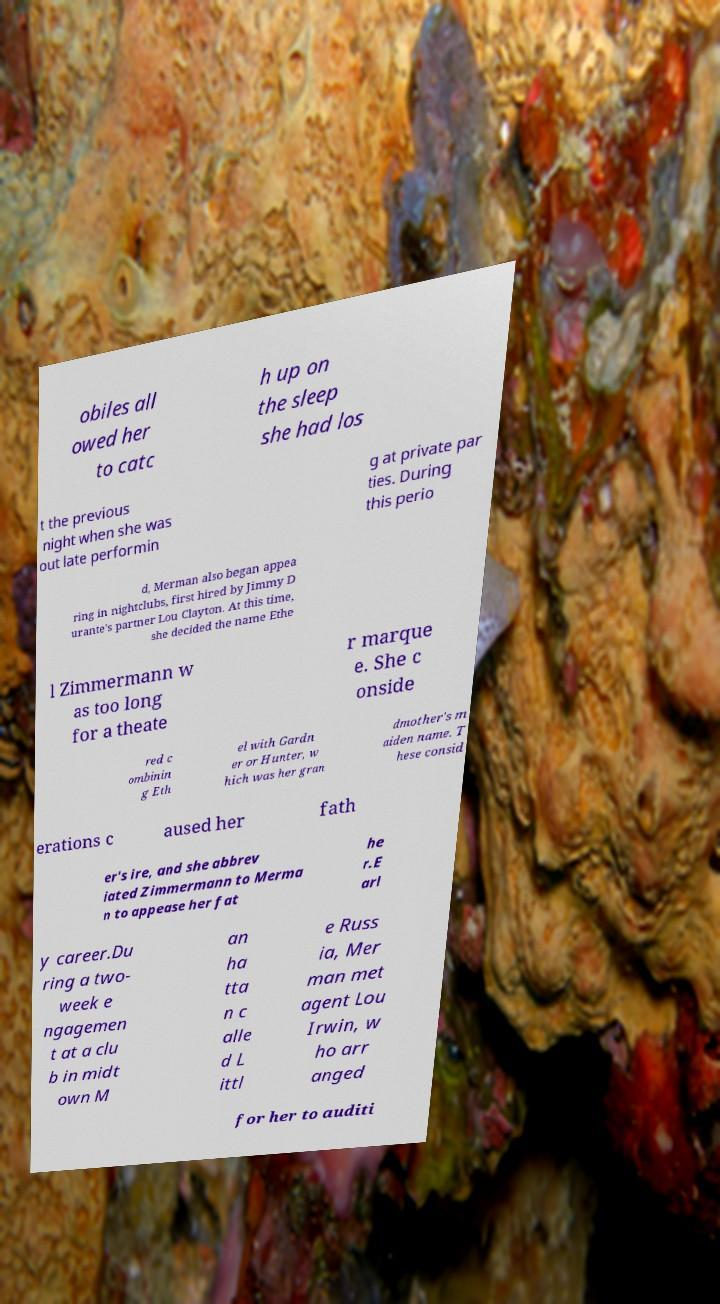Please identify and transcribe the text found in this image. obiles all owed her to catc h up on the sleep she had los t the previous night when she was out late performin g at private par ties. During this perio d, Merman also began appea ring in nightclubs, first hired by Jimmy D urante's partner Lou Clayton. At this time, she decided the name Ethe l Zimmermann w as too long for a theate r marque e. She c onside red c ombinin g Eth el with Gardn er or Hunter, w hich was her gran dmother's m aiden name. T hese consid erations c aused her fath er's ire, and she abbrev iated Zimmermann to Merma n to appease her fat he r.E arl y career.Du ring a two- week e ngagemen t at a clu b in midt own M an ha tta n c alle d L ittl e Russ ia, Mer man met agent Lou Irwin, w ho arr anged for her to auditi 